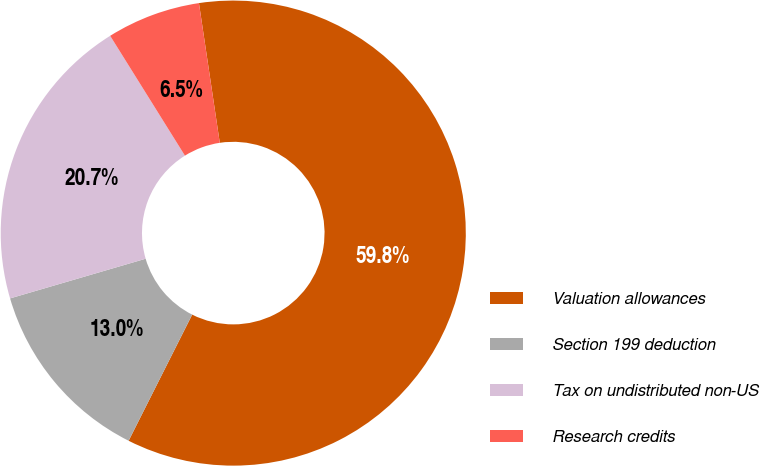<chart> <loc_0><loc_0><loc_500><loc_500><pie_chart><fcel>Valuation allowances<fcel>Section 199 deduction<fcel>Tax on undistributed non-US<fcel>Research credits<nl><fcel>59.78%<fcel>13.04%<fcel>20.65%<fcel>6.52%<nl></chart> 